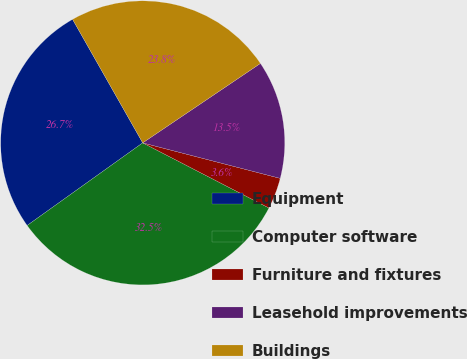Convert chart. <chart><loc_0><loc_0><loc_500><loc_500><pie_chart><fcel>Equipment<fcel>Computer software<fcel>Furniture and fixtures<fcel>Leasehold improvements<fcel>Buildings<nl><fcel>26.66%<fcel>32.54%<fcel>3.56%<fcel>13.47%<fcel>23.77%<nl></chart> 